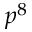<formula> <loc_0><loc_0><loc_500><loc_500>p ^ { 8 }</formula> 